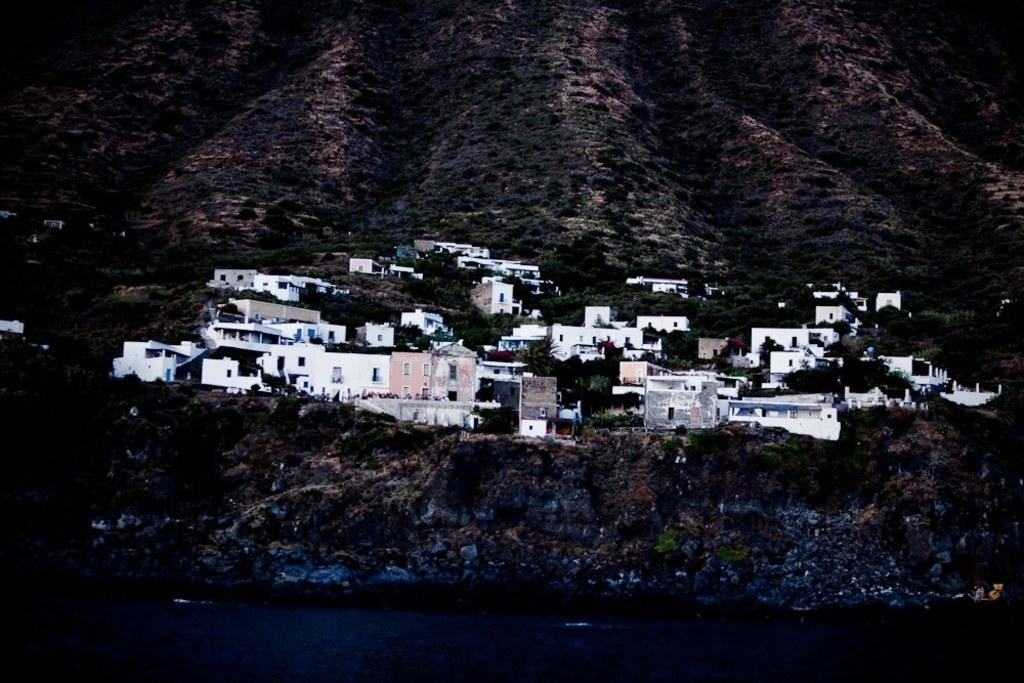What can be seen on the mountain in the image? There are houses and trees on the mountain in the image. Can you describe the landscape at the bottom of the image? Water is visible at the bottom of the image. How many screws can be seen holding the houses together on the mountain in the image? There are no screws visible in the image; the houses are not being held together by screws. 